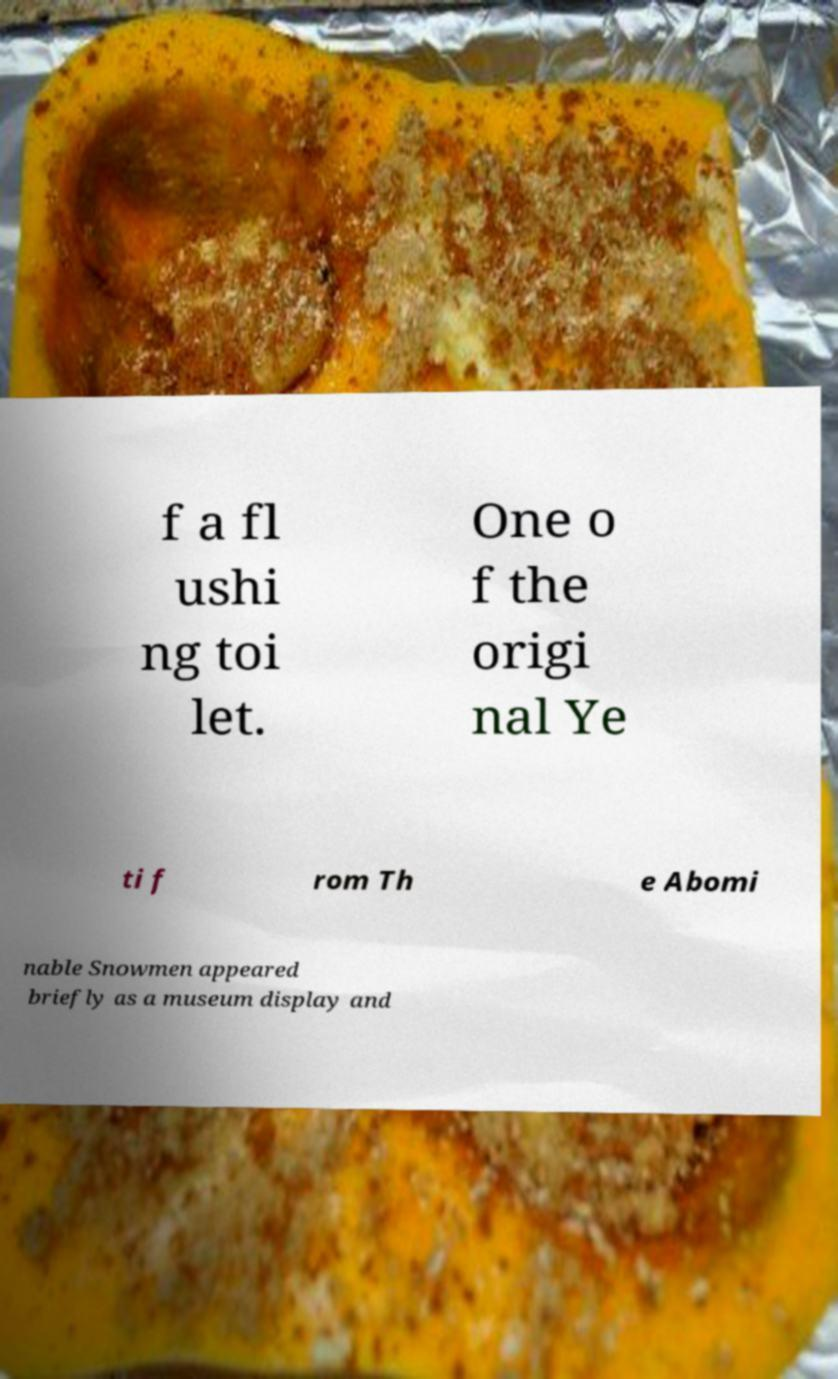Can you accurately transcribe the text from the provided image for me? f a fl ushi ng toi let. One o f the origi nal Ye ti f rom Th e Abomi nable Snowmen appeared briefly as a museum display and 